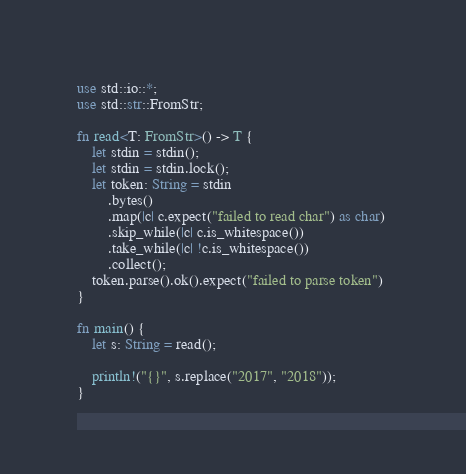<code> <loc_0><loc_0><loc_500><loc_500><_Rust_>use std::io::*;
use std::str::FromStr;

fn read<T: FromStr>() -> T {
    let stdin = stdin();
    let stdin = stdin.lock();
    let token: String = stdin
        .bytes()
        .map(|c| c.expect("failed to read char") as char) 
        .skip_while(|c| c.is_whitespace())
        .take_while(|c| !c.is_whitespace())
        .collect();
    token.parse().ok().expect("failed to parse token")
}

fn main() {
    let s: String = read();

    println!("{}", s.replace("2017", "2018"));
}
</code> 